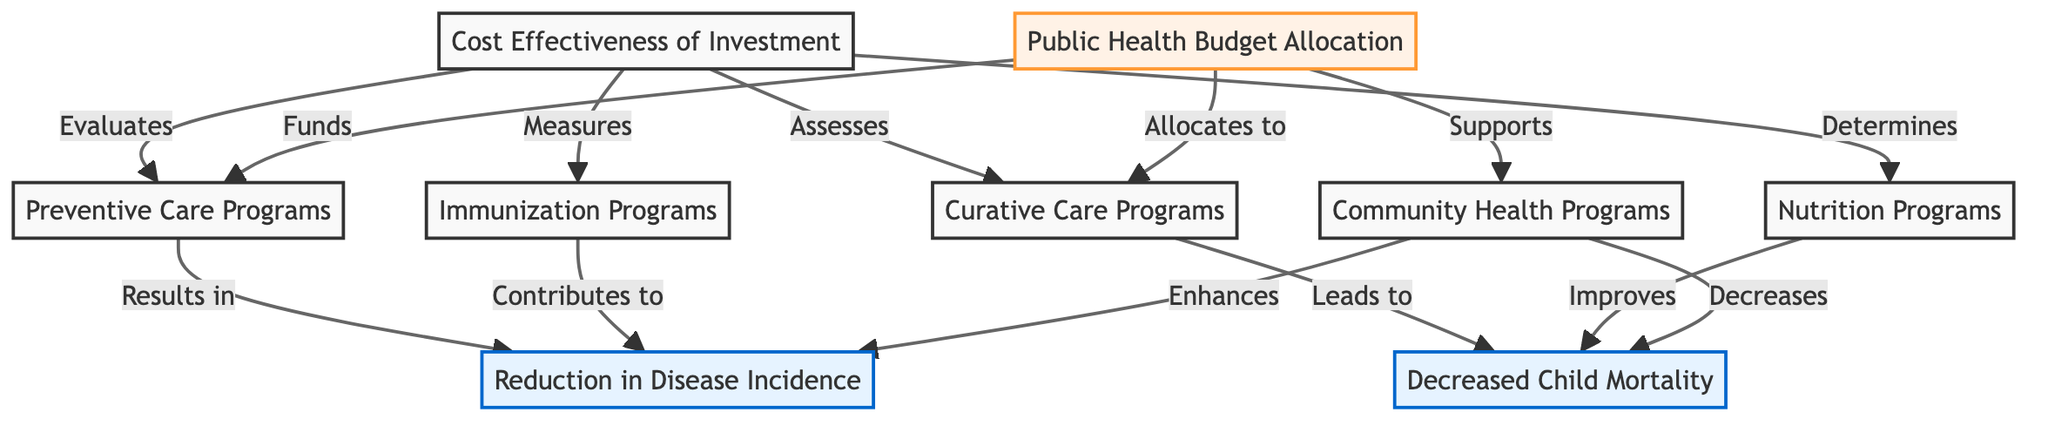What types of programs are represented in this diagram? The diagram includes four types of pediatric healthcare programs: preventive care programs, curative care programs, immunization programs, and nutrition programs. These are explicitly labeled as nodes in the diagram.
Answer: Preventive Care Programs, Curative Care Programs, Immunization Programs, Nutrition Programs Which program is directly linked to decreased child mortality? Curative care programs and nutrition programs are both connected to the outcome of decreased child mortality in the diagram. However, since the question asks for a specific link, we will consider curative care as the first identified factor linked in the structure.
Answer: Curative Care Programs How many total outcomes are represented in the diagram? There are two outcomes explicitly represented in the diagram: reduction in disease incidence and decreased child mortality. The node count provides the specific characteristics under outcomes to identify.
Answer: 2 What role does the public health budget play in the program structure? The public health budget supports the community health programs, funds preventive care, and allocates resources to curative care, indicating its importance in financing and enhancing the pediatric healthcare programs as displayed in the connections.
Answer: Supports, Funds, Allocates What is the relationship between community health programs and the outcomes? Community health programs enhance the reduction in disease incidence and decrease child mortality, indicating their significant positive impact on health outcomes as established by their respective links in the diagram.
Answer: Enhances, Decreases How is cost-effectiveness evaluated in relation to the programs? Cost-effectiveness is evaluated by assessing preventive care, measuring the impact of immunization, evaluating curative care, and determining the effectiveness of nutrition programs, as shown by their interconnectedness with the investment cost-effectiveness node.
Answer: Evaluates, Assesses, Measures, Determines Which program contributes to the reduction in disease incidence? Both preventive care programs and immunization programs directly contribute to the reduction in disease incidence as these relationships are clearly indicated in the diagram. Since both are present, we will note preventive care programs as they are presented first in the structure.
Answer: Preventive Care Programs 